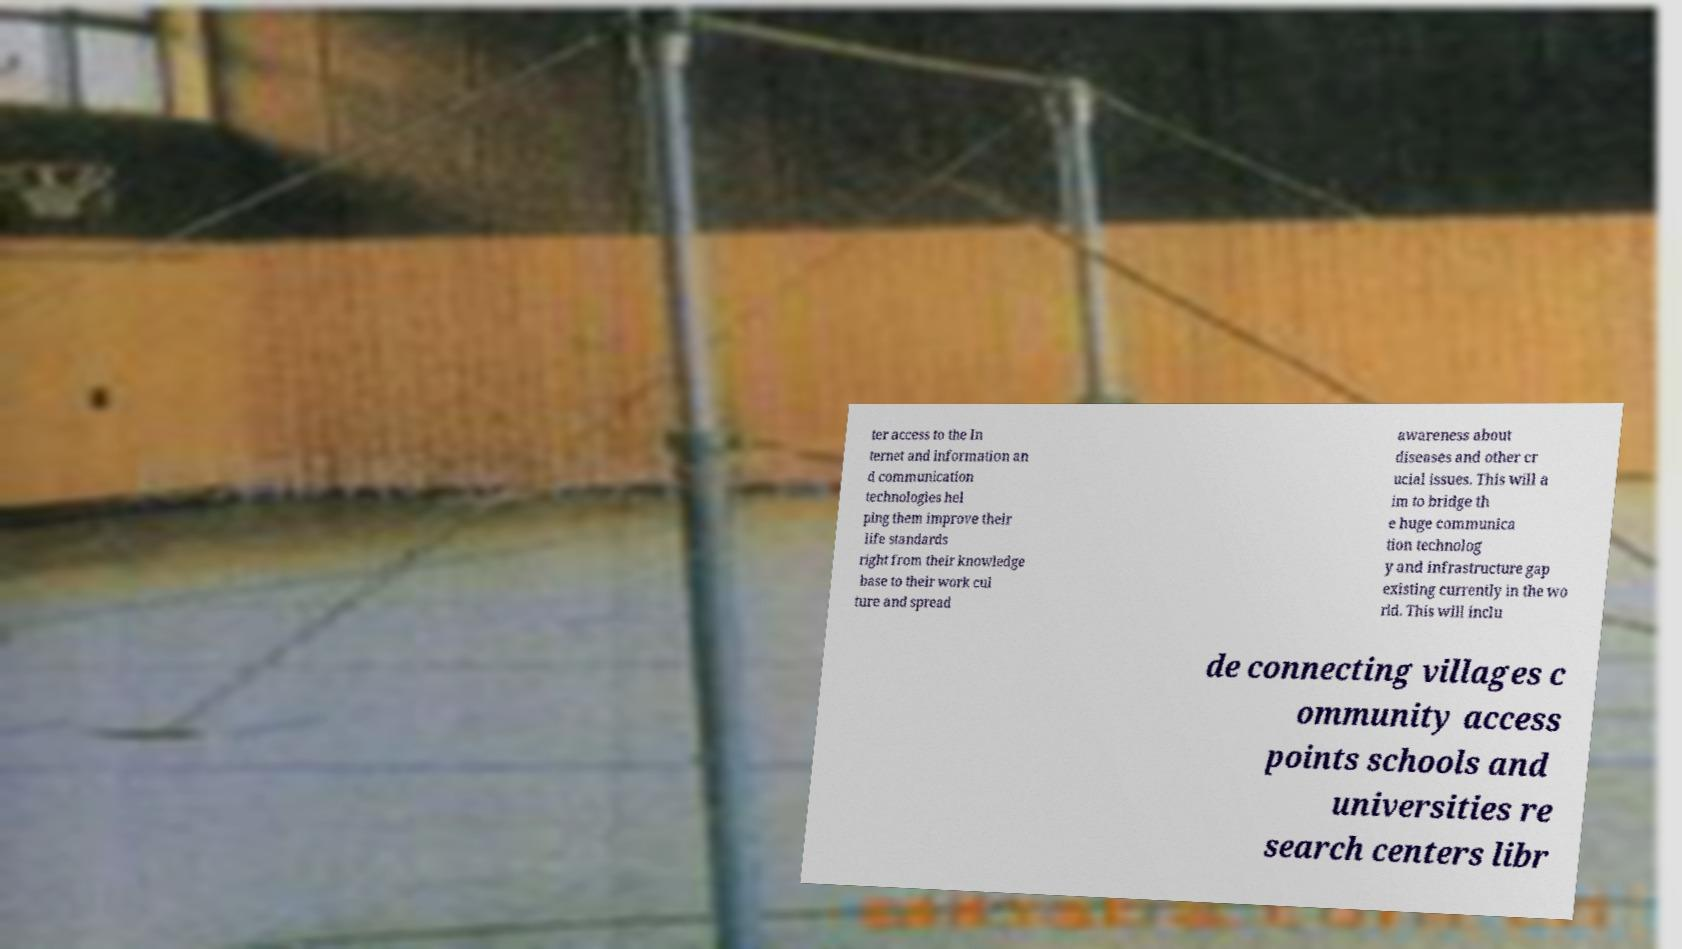What messages or text are displayed in this image? I need them in a readable, typed format. ter access to the In ternet and information an d communication technologies hel ping them improve their life standards right from their knowledge base to their work cul ture and spread awareness about diseases and other cr ucial issues. This will a im to bridge th e huge communica tion technolog y and infrastructure gap existing currently in the wo rld. This will inclu de connecting villages c ommunity access points schools and universities re search centers libr 